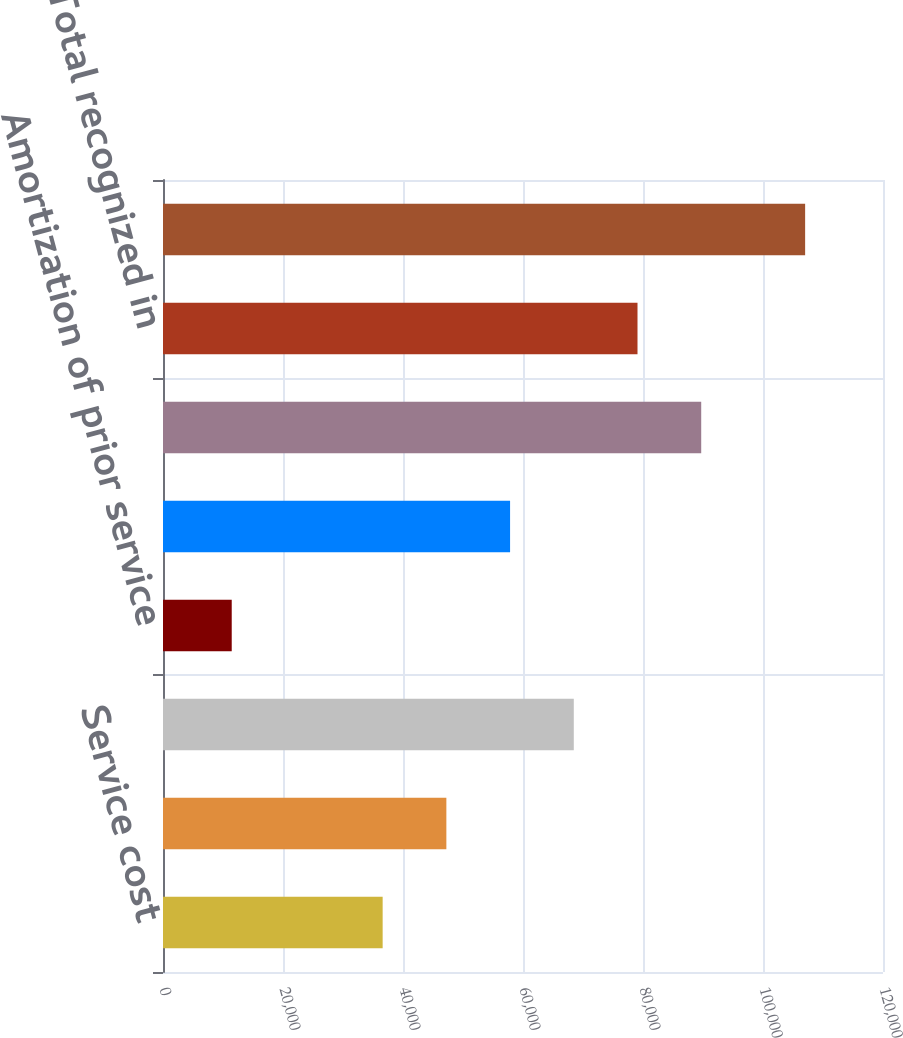<chart> <loc_0><loc_0><loc_500><loc_500><bar_chart><fcel>Service cost<fcel>Interest cost<fcel>Expected return on plan assets<fcel>Amortization of prior service<fcel>Net periodic benefit cost<fcel>Net loss (gain)<fcel>Total recognized in<fcel>TOTAL RECOGNIZED IN NET<nl><fcel>36609<fcel>47227.6<fcel>68464.8<fcel>11454.6<fcel>57846.2<fcel>89702<fcel>79083.4<fcel>107022<nl></chart> 